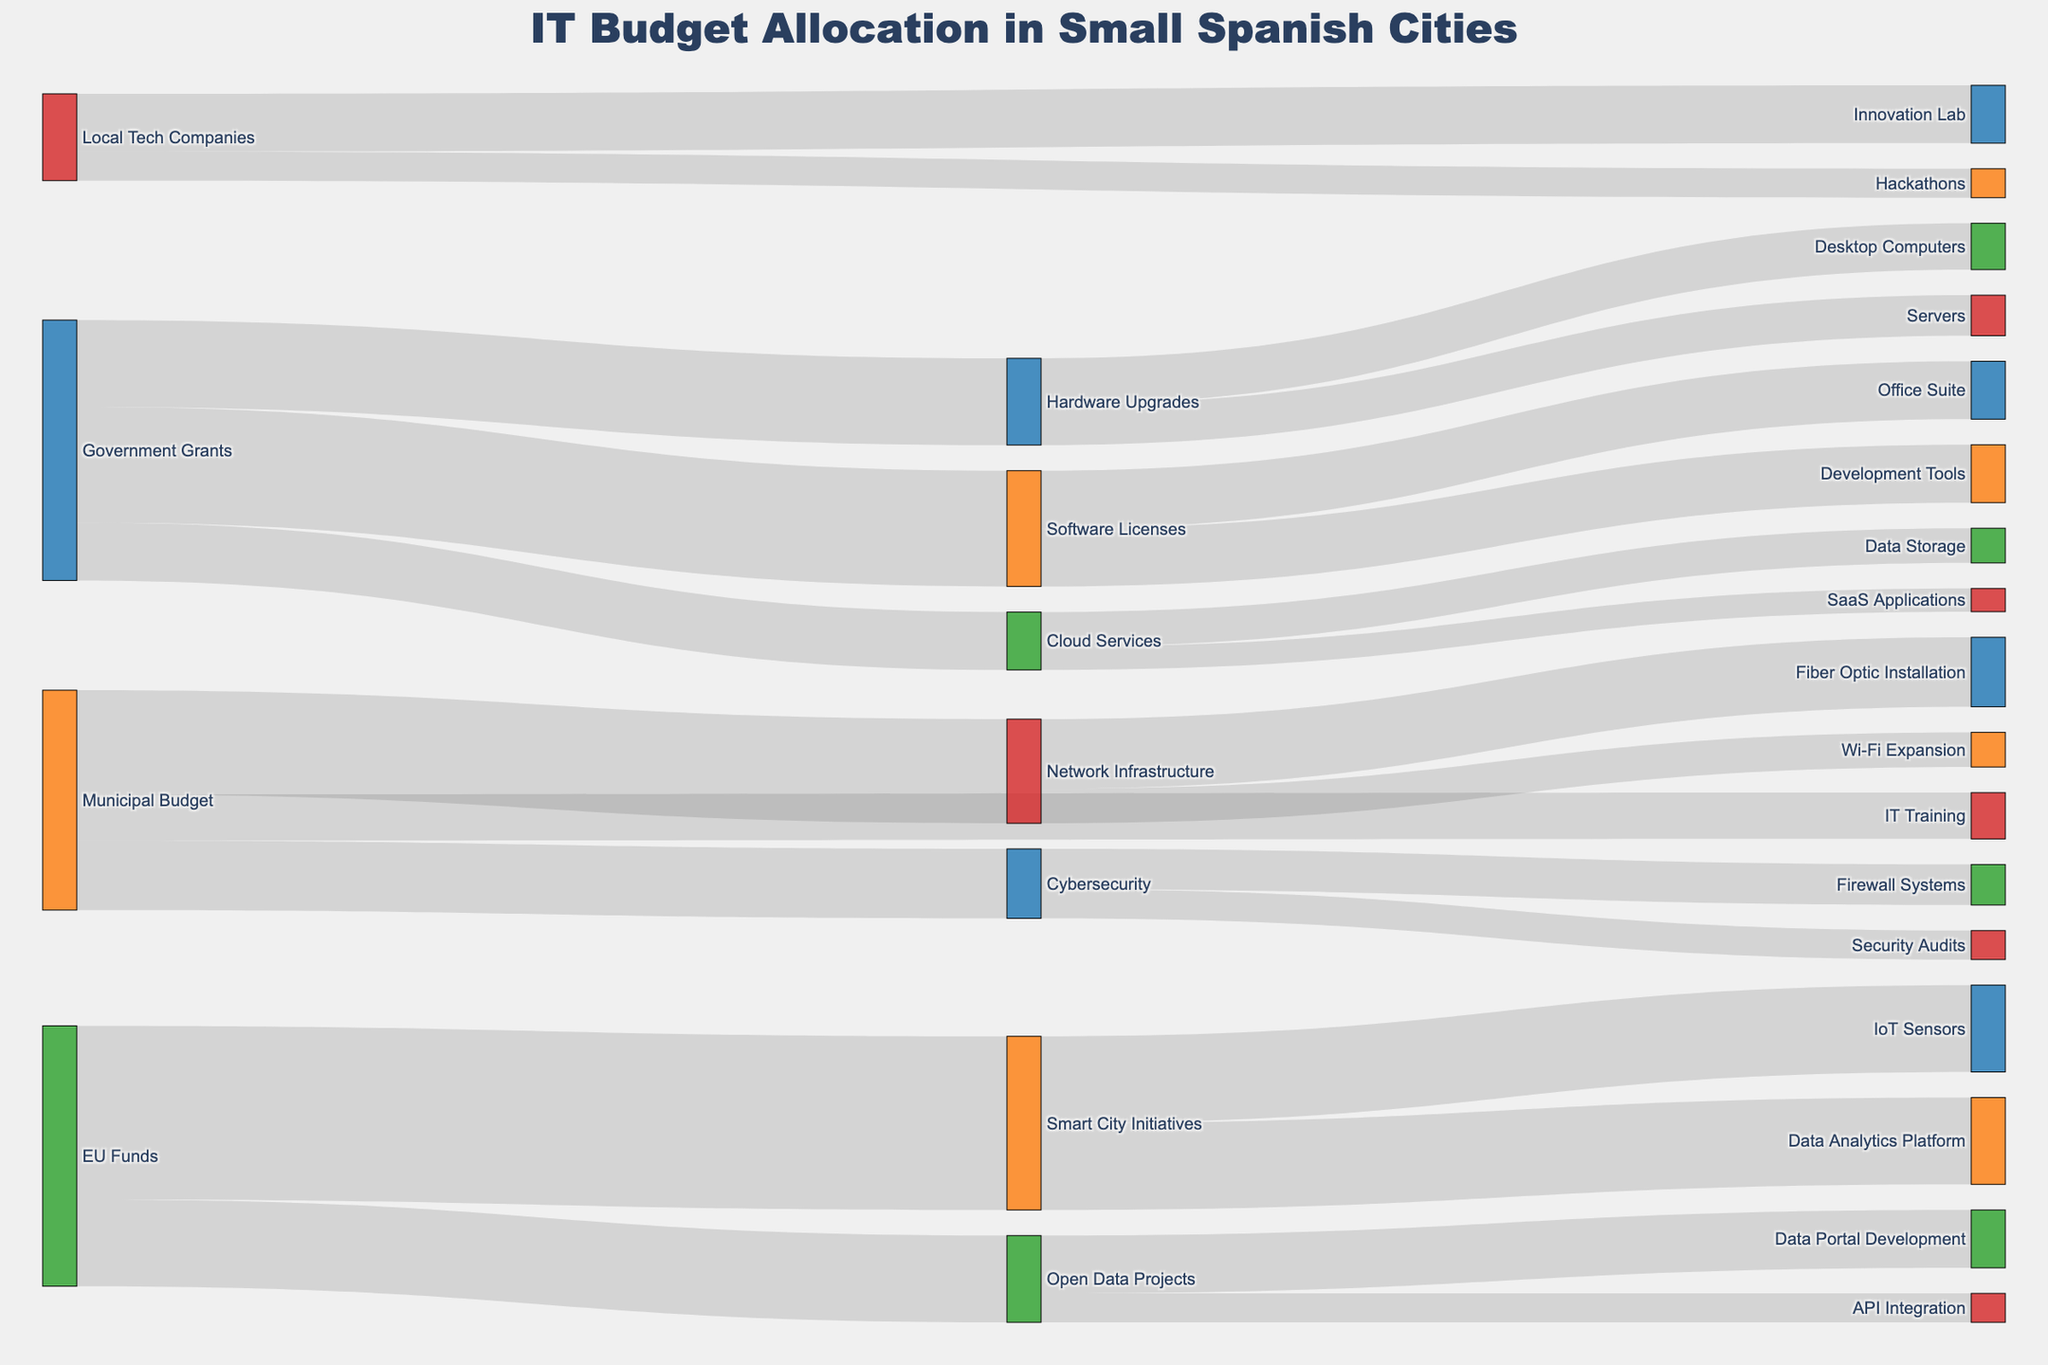What is the largest funding source for IT projects in small Spanish cities? To find the largest funding source, look at the total value attributed to each source. Government Grants totals 450,000 (150,000 from Hardware Upgrades + 200,000 from Software Licenses + 100,000 from Cloud Services), which is the highest compared to the other sources.
Answer: Government Grants Where is the most considerable portion of the Cybersecurity budget allocated? Based on the budget allocation for Cybersecurity, 70,000 is for Firewall Systems, and 50,000 is for Security Audits. The largest portion is therefore allocated to Firewall Systems.
Answer: Firewall Systems What is the total amount of EU Funds allocated and what are the key projects funded by this source? EU Funds are allocated to Smart City Initiatives and Open Data Projects. The total amount is 450,000 (300,000 for Smart City Initiatives + 150,000 for Open Data Projects). The key projects are Smart City Initiatives and Open Data Projects.
Answer: 450,000, Smart City Initiatives, Open Data Projects Compare the total budget allocated to Network Infrastructure and Cybersecurity. Which receives more funding? Network Infrastructure receives 180,000 (120,000 for Fiber Optic Installation + 60,000 for Wi-Fi Expansion) while Cybersecurity receives 120,000 (70,000 for Firewall Systems + 50,000 for Security Audits). Network Infrastructure has more funding.
Answer: Network Infrastructure How does the funding for Innovation Lab compare to Hackathons from Local Tech Companies? Local Tech Companies allocate 100,000 to Innovation Lab and 50,000 to Hackathons. Innovation Lab receives twice as much funding compared to Hackathons.
Answer: Innovation Lab Which specific investment under Smart City Initiatives has the same amount allocated as API Integration in Open Data Projects? Under Smart City Initiatives, IoT Sensors and Data Analytics Platform each receive 150,000, which matches the 50,000 allocated to API Integration in Open Data Projects.
Answer: IoT Sensors, Data Analytics Platform Which source provides funding for IT Training, and what is the amount allocated? The Municipal Budget provides funding for IT Training, with an amount allocated of 80,000.
Answer: Municipal Budget, 80,000 Is there any specific technology investment that receives equal funding from two different sources? Software Licenses and Smart City Initiatives each receive 200,000 and 300,000 respectively, compared to others, no specific technology investment receiving equal funding from multiple sources is evident.
Answer: No What are the components of the Cloud Services allocation? Cloud Services allocation consists of Data Storage receiving 60,000 and SaaS Applications receiving 40,000.
Answer: Data Storage, SaaS Applications 